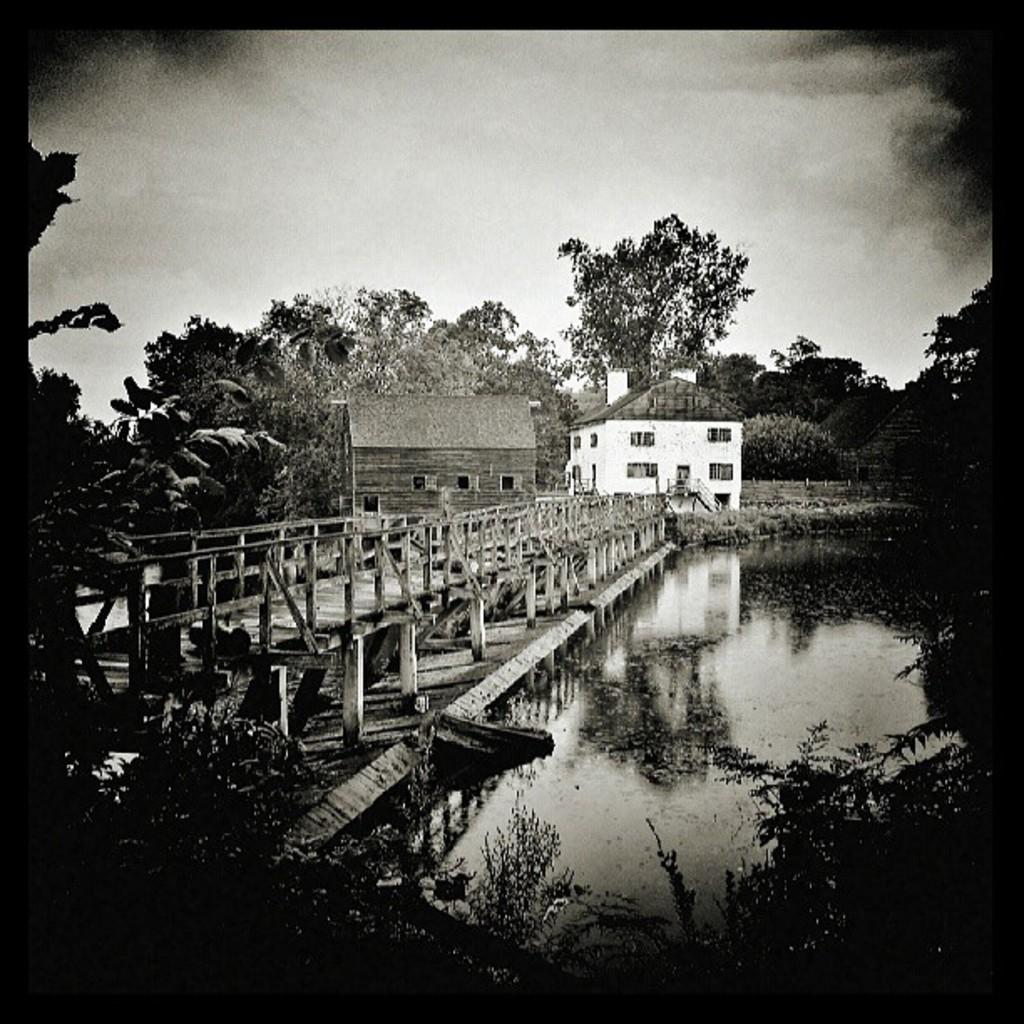What is the main structure in the center of the image? There is a house in the center of the image. What type of bridge can be seen in the image? There is a wooden bridge in the image. What type of vegetation is present in the image? There are trees in the image. What natural element is visible in the image? There is water visible in the image. What type of stick is being used by the woman in the image? There is no woman or stick present in the image. 